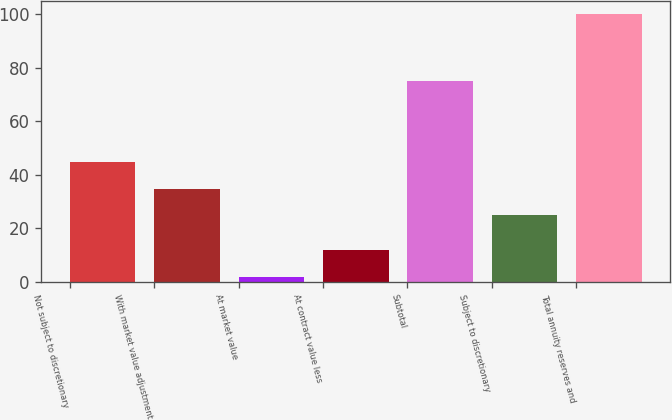Convert chart to OTSL. <chart><loc_0><loc_0><loc_500><loc_500><bar_chart><fcel>Not subject to discretionary<fcel>With market value adjustment<fcel>At market value<fcel>At contract value less<fcel>Subtotal<fcel>Subject to discretionary<fcel>Total annuity reserves and<nl><fcel>44.6<fcel>34.8<fcel>2<fcel>11.8<fcel>75<fcel>25<fcel>100<nl></chart> 